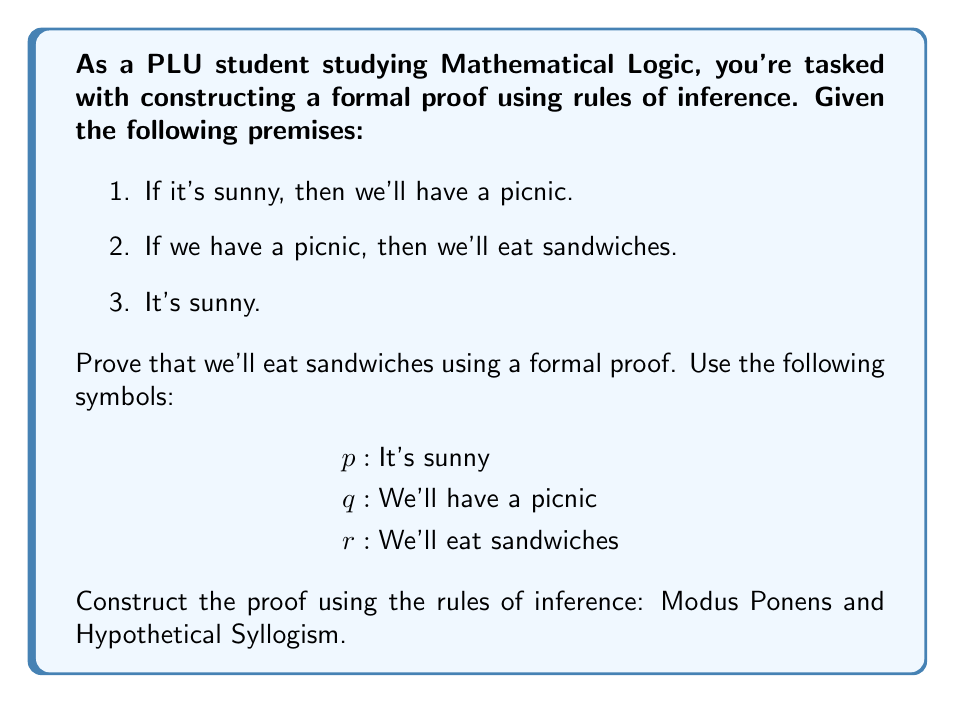Solve this math problem. Let's construct the formal proof step-by-step:

1. First, let's identify our premises in symbolic form:
   a. $p \rightarrow q$ (If it's sunny, then we'll have a picnic)
   b. $q \rightarrow r$ (If we have a picnic, then we'll eat sandwiches)
   c. $p$ (It's sunny)

2. We'll use these premises to prove $r$ (We'll eat sandwiches).

3. The proof:
   
   Step 1: $p \rightarrow q$ (Premise 1)
   Step 2: $p$ (Premise 3)
   Step 3: $q$ (Modus Ponens, Steps 1 and 2)
   
   Explanation: We use Modus Ponens here. The rule states that if we have $p \rightarrow q$ and $p$, we can conclude $q$.

   Step 4: $q \rightarrow r$ (Premise 2)
   Step 5: $r$ (Modus Ponens, Steps 3 and 4)
   
   Explanation: We use Modus Ponens again. We have $q \rightarrow r$ and $q$ (from Step 3), so we can conclude $r$.

Alternatively, we could have used Hypothetical Syllogism in the following way:

   Step 1: $p \rightarrow q$ (Premise 1)
   Step 2: $q \rightarrow r$ (Premise 2)
   Step 3: $p \rightarrow r$ (Hypothetical Syllogism, Steps 1 and 2)
   Step 4: $p$ (Premise 3)
   Step 5: $r$ (Modus Ponens, Steps 3 and 4)

Both methods are valid and lead to the same conclusion.
Answer: $r$ (We'll eat sandwiches) 